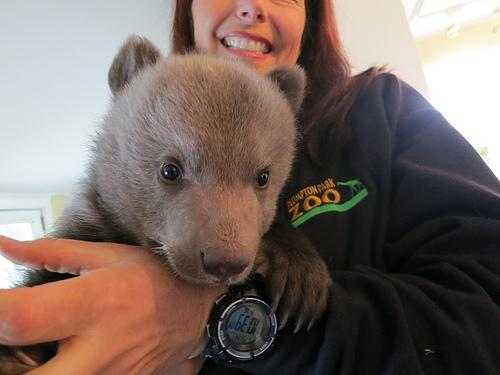Give an overview of the picture without mentioning the bear. A smiling woman with red hair wearing a black sweatshirt with a zoo logo is carrying an animal in her arms and has a black wristwatch on her hand. Give a brief description of the central figure in the image. A light-skinned woman with red hair is holding a young gray bear cub and smiling. What is the interaction between the person and the animal in the image? The woman is holding and carrying the gray bear cub in her arms. What animal is being held by the woman in the photo? The woman is holding a young gray bear cub. Mention an important detail about the woman's face. The woman has a bright smile on her face. Describe the clothing worn by the person in the image. The woman is wearing a black sweatshirt with a zoo logo embroidered on it. Present a concise summary of the image. A light-skinned, red-haired woman wearing a black sweatshirt with a zoo logo is smiling and holding a young gray bear cub in her arms. What accessory is the woman wearing on her wrist? The woman is wearing a black wristwatch on her hand. Identify a notable feature of the bear's face. The eyes on the bear's face are black. What is an interesting aspect of the woman's attire? The zoo logo on the woman's shirt is a notable feature. 